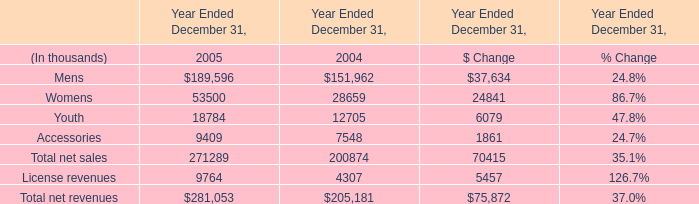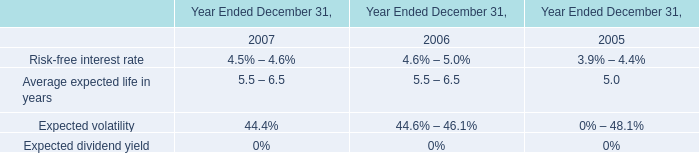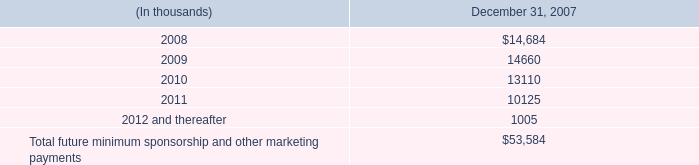What is the sum of the Accessories in the years where Mens for Year Ended December 31 is positive? (in thousand) 
Computations: (9409 + 7548)
Answer: 16957.0. 